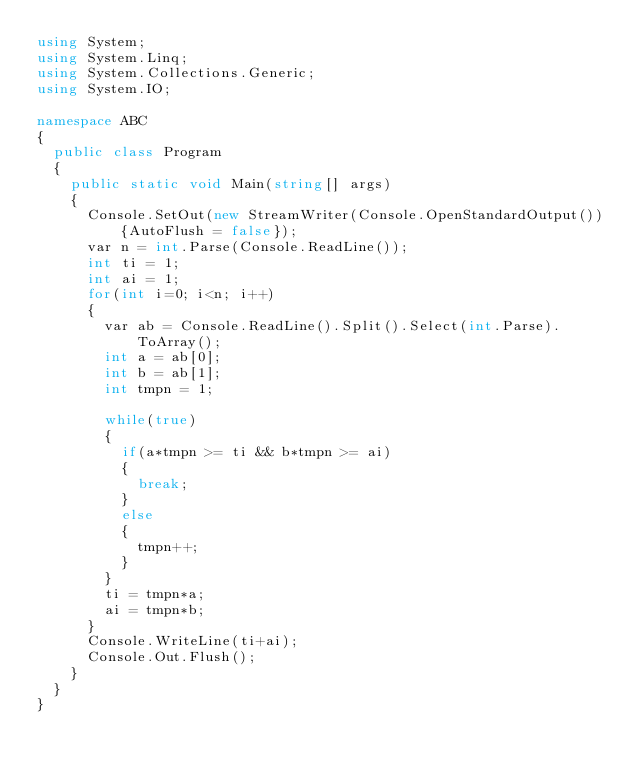<code> <loc_0><loc_0><loc_500><loc_500><_C#_>using System;
using System.Linq;
using System.Collections.Generic;
using System.IO;
 
namespace ABC
{
  public class Program
  {
    public static void Main(string[] args)
    {
      Console.SetOut(new StreamWriter(Console.OpenStandardOutput()){AutoFlush = false});
      var n = int.Parse(Console.ReadLine());
      int ti = 1;
      int ai = 1;
      for(int i=0; i<n; i++)
      {
        var ab = Console.ReadLine().Split().Select(int.Parse).ToArray();
        int a = ab[0];
        int b = ab[1];
        int tmpn = 1;
        
        while(true)
        {
          if(a*tmpn >= ti && b*tmpn >= ai)
          {
            break;
          }
          else
          {
            tmpn++;
          }
        }
        ti = tmpn*a;
        ai = tmpn*b;
      }
      Console.WriteLine(ti+ai);
      Console.Out.Flush();
    }
  }
}
</code> 